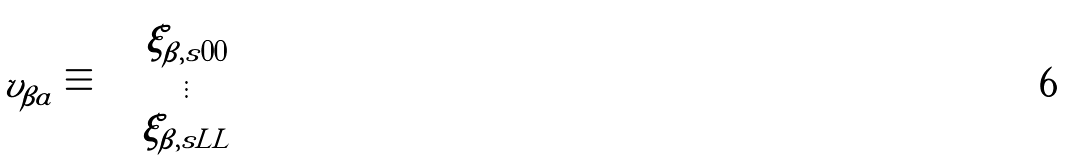Convert formula to latex. <formula><loc_0><loc_0><loc_500><loc_500>v _ { \beta a } \equiv \left [ \begin{array} { c } \xi _ { \beta , s 0 0 } \\ \vdots \\ \xi _ { \beta , s L L } \end{array} \right ]</formula> 